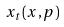<formula> <loc_0><loc_0><loc_500><loc_500>x _ { t } ( x , p )</formula> 